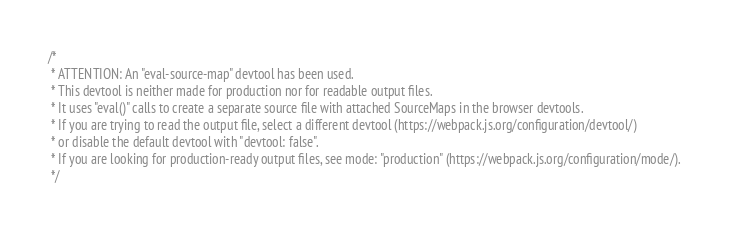<code> <loc_0><loc_0><loc_500><loc_500><_JavaScript_>/*
 * ATTENTION: An "eval-source-map" devtool has been used.
 * This devtool is neither made for production nor for readable output files.
 * It uses "eval()" calls to create a separate source file with attached SourceMaps in the browser devtools.
 * If you are trying to read the output file, select a different devtool (https://webpack.js.org/configuration/devtool/)
 * or disable the default devtool with "devtool: false".
 * If you are looking for production-ready output files, see mode: "production" (https://webpack.js.org/configuration/mode/).
 */</code> 